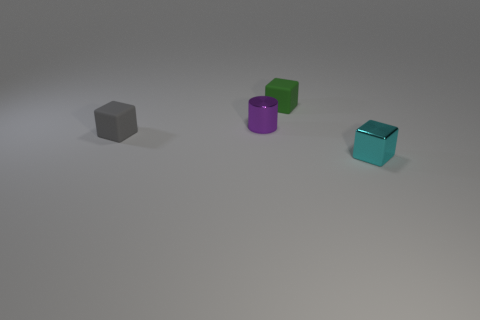Can you guess the lighting setup based on the shadows of the objects? The shadows cast by the objects are soft-edged and extend predominantly to one side, suggesting a single, diffused light source located above and possibly slightly to the opposite side of where the shadows fall. This setup results in a gentle illumination that creates visible but not harsh definition. 